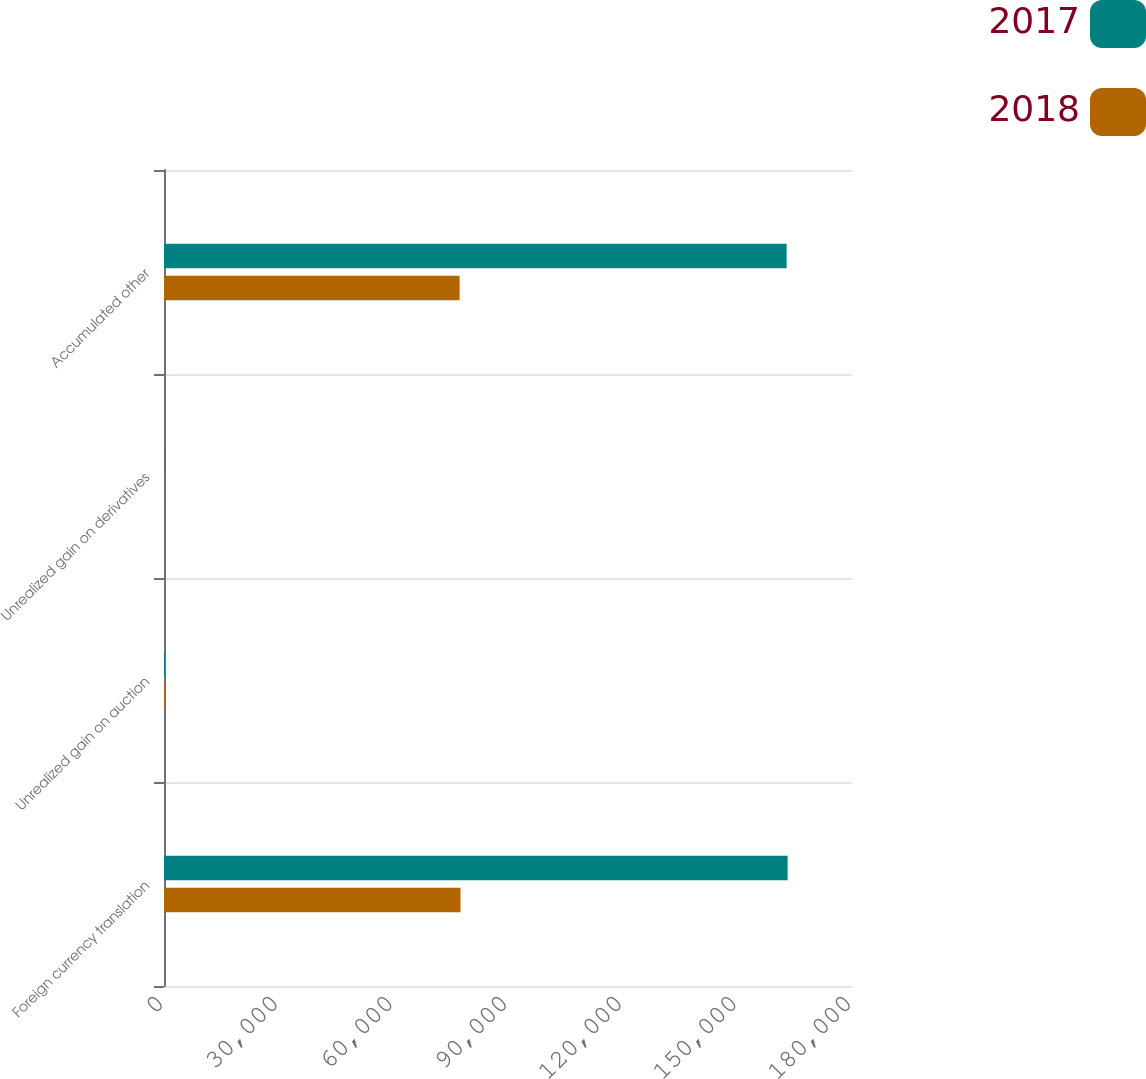Convert chart. <chart><loc_0><loc_0><loc_500><loc_500><stacked_bar_chart><ecel><fcel>Foreign currency translation<fcel>Unrealized gain on auction<fcel>Unrealized gain on derivatives<fcel>Accumulated other<nl><fcel>2017<fcel>163155<fcel>232<fcel>27<fcel>162896<nl><fcel>2018<fcel>77578<fcel>232<fcel>2<fcel>77344<nl></chart> 